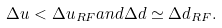Convert formula to latex. <formula><loc_0><loc_0><loc_500><loc_500>\Delta u < \Delta u _ { R F } a n d \Delta d \simeq \Delta d _ { R F } .</formula> 